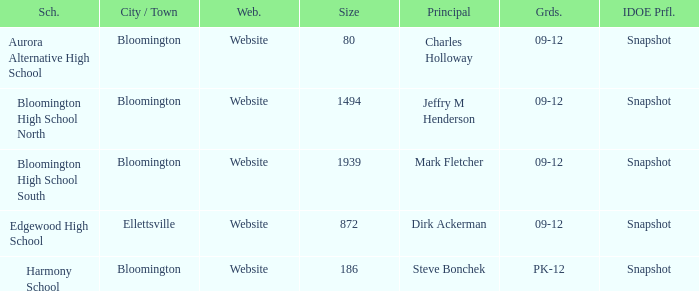Where is Bloomington High School North? Bloomington. 